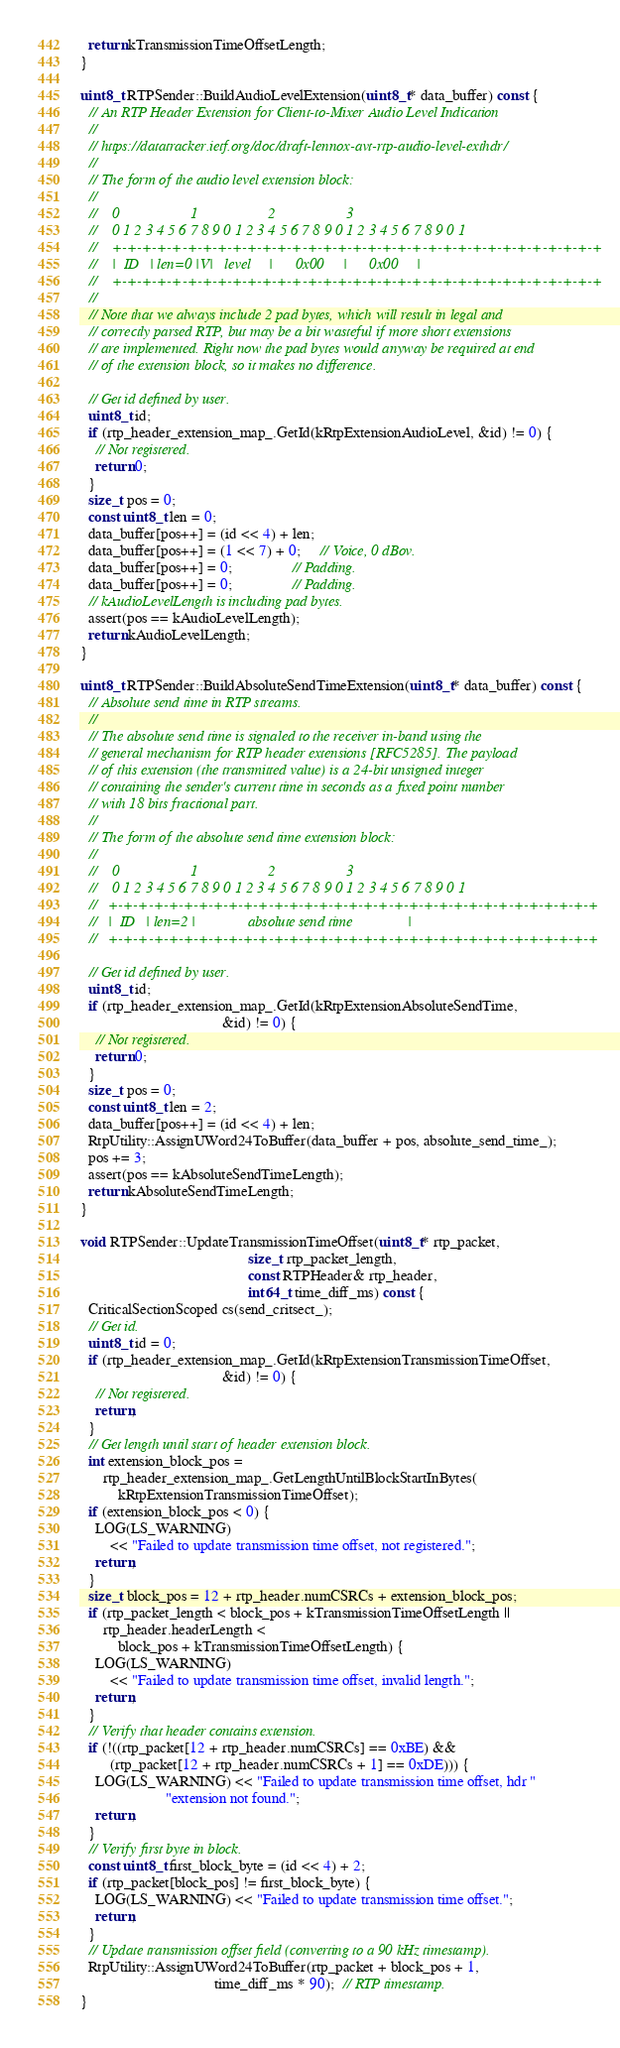<code> <loc_0><loc_0><loc_500><loc_500><_C++_>  return kTransmissionTimeOffsetLength;
}

uint8_t RTPSender::BuildAudioLevelExtension(uint8_t* data_buffer) const {
  // An RTP Header Extension for Client-to-Mixer Audio Level Indication
  //
  // https://datatracker.ietf.org/doc/draft-lennox-avt-rtp-audio-level-exthdr/
  //
  // The form of the audio level extension block:
  //
  //    0                   1                   2                   3
  //    0 1 2 3 4 5 6 7 8 9 0 1 2 3 4 5 6 7 8 9 0 1 2 3 4 5 6 7 8 9 0 1
  //    +-+-+-+-+-+-+-+-+-+-+-+-+-+-+-+-+-+-+-+-+-+-+-+-+-+-+-+-+-+-+-+-+
  //    |  ID   | len=0 |V|   level     |      0x00     |      0x00     |
  //    +-+-+-+-+-+-+-+-+-+-+-+-+-+-+-+-+-+-+-+-+-+-+-+-+-+-+-+-+-+-+-+-+
  //
  // Note that we always include 2 pad bytes, which will result in legal and
  // correctly parsed RTP, but may be a bit wasteful if more short extensions
  // are implemented. Right now the pad bytes would anyway be required at end
  // of the extension block, so it makes no difference.

  // Get id defined by user.
  uint8_t id;
  if (rtp_header_extension_map_.GetId(kRtpExtensionAudioLevel, &id) != 0) {
    // Not registered.
    return 0;
  }
  size_t pos = 0;
  const uint8_t len = 0;
  data_buffer[pos++] = (id << 4) + len;
  data_buffer[pos++] = (1 << 7) + 0;     // Voice, 0 dBov.
  data_buffer[pos++] = 0;                // Padding.
  data_buffer[pos++] = 0;                // Padding.
  // kAudioLevelLength is including pad bytes.
  assert(pos == kAudioLevelLength);
  return kAudioLevelLength;
}

uint8_t RTPSender::BuildAbsoluteSendTimeExtension(uint8_t* data_buffer) const {
  // Absolute send time in RTP streams.
  //
  // The absolute send time is signaled to the receiver in-band using the
  // general mechanism for RTP header extensions [RFC5285]. The payload
  // of this extension (the transmitted value) is a 24-bit unsigned integer
  // containing the sender's current time in seconds as a fixed point number
  // with 18 bits fractional part.
  //
  // The form of the absolute send time extension block:
  //
  //    0                   1                   2                   3
  //    0 1 2 3 4 5 6 7 8 9 0 1 2 3 4 5 6 7 8 9 0 1 2 3 4 5 6 7 8 9 0 1
  //   +-+-+-+-+-+-+-+-+-+-+-+-+-+-+-+-+-+-+-+-+-+-+-+-+-+-+-+-+-+-+-+-+
  //   |  ID   | len=2 |              absolute send time               |
  //   +-+-+-+-+-+-+-+-+-+-+-+-+-+-+-+-+-+-+-+-+-+-+-+-+-+-+-+-+-+-+-+-+

  // Get id defined by user.
  uint8_t id;
  if (rtp_header_extension_map_.GetId(kRtpExtensionAbsoluteSendTime,
                                      &id) != 0) {
    // Not registered.
    return 0;
  }
  size_t pos = 0;
  const uint8_t len = 2;
  data_buffer[pos++] = (id << 4) + len;
  RtpUtility::AssignUWord24ToBuffer(data_buffer + pos, absolute_send_time_);
  pos += 3;
  assert(pos == kAbsoluteSendTimeLength);
  return kAbsoluteSendTimeLength;
}

void RTPSender::UpdateTransmissionTimeOffset(uint8_t* rtp_packet,
                                             size_t rtp_packet_length,
                                             const RTPHeader& rtp_header,
                                             int64_t time_diff_ms) const {
  CriticalSectionScoped cs(send_critsect_);
  // Get id.
  uint8_t id = 0;
  if (rtp_header_extension_map_.GetId(kRtpExtensionTransmissionTimeOffset,
                                      &id) != 0) {
    // Not registered.
    return;
  }
  // Get length until start of header extension block.
  int extension_block_pos =
      rtp_header_extension_map_.GetLengthUntilBlockStartInBytes(
          kRtpExtensionTransmissionTimeOffset);
  if (extension_block_pos < 0) {
    LOG(LS_WARNING)
        << "Failed to update transmission time offset, not registered.";
    return;
  }
  size_t block_pos = 12 + rtp_header.numCSRCs + extension_block_pos;
  if (rtp_packet_length < block_pos + kTransmissionTimeOffsetLength ||
      rtp_header.headerLength <
          block_pos + kTransmissionTimeOffsetLength) {
    LOG(LS_WARNING)
        << "Failed to update transmission time offset, invalid length.";
    return;
  }
  // Verify that header contains extension.
  if (!((rtp_packet[12 + rtp_header.numCSRCs] == 0xBE) &&
        (rtp_packet[12 + rtp_header.numCSRCs + 1] == 0xDE))) {
    LOG(LS_WARNING) << "Failed to update transmission time offset, hdr "
                       "extension not found.";
    return;
  }
  // Verify first byte in block.
  const uint8_t first_block_byte = (id << 4) + 2;
  if (rtp_packet[block_pos] != first_block_byte) {
    LOG(LS_WARNING) << "Failed to update transmission time offset.";
    return;
  }
  // Update transmission offset field (converting to a 90 kHz timestamp).
  RtpUtility::AssignUWord24ToBuffer(rtp_packet + block_pos + 1,
                                    time_diff_ms * 90);  // RTP timestamp.
}
</code> 